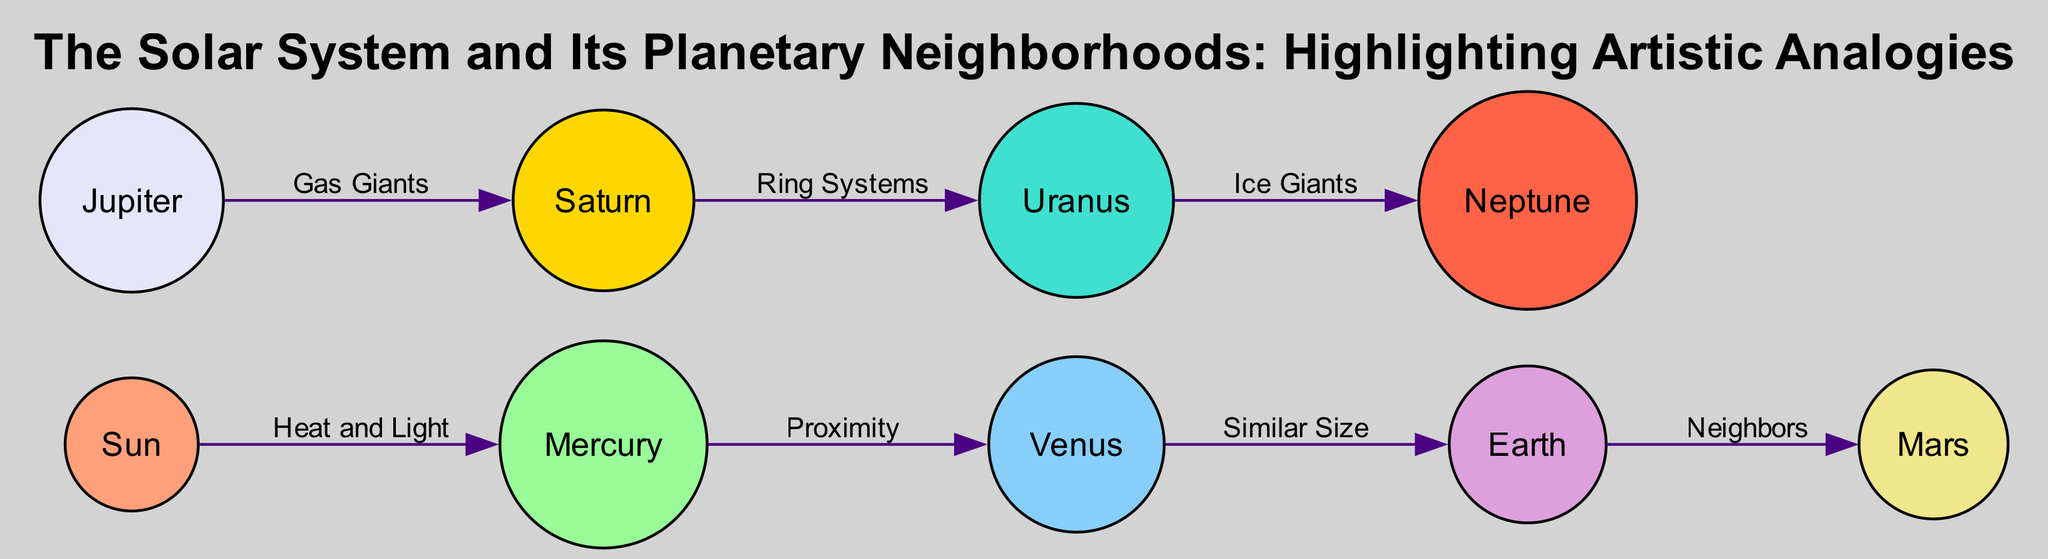What is the central star in the diagram? The diagram labels the "Sun" as the central star, indicating its importance in the solar system and art analogy.
Answer: Sun How many planets are depicted in the diagram? Counting the nodes labeled with planet names, there are eight planets present in the diagram.
Answer: Eight Which planet is symbolized by fiery passion? The description for "Mars" explicitly ties it to the symbolism of fiery passion in creativity.
Answer: Mars What connects Earth to Mars in the diagram? The edge labeled "Neighbors" highlights the direct connection and proximity of Earth to Mars.
Answer: Neighbors Which planets are categorized as gas giants? The diagram indicates that "Jupiter" and "Saturn" are linked by the label "Gas Giants", marking them as a specific category of planets.
Answer: Jupiter and Saturn How does Venus relate to Earth? The edge labeled "Similar Size" shows that Venus is directly connected to Earth, emphasizing their comparative dimensions.
Answer: Similar Size What does Saturn represent in the artistic analogies? The description states that "Saturn" illustrates intricate details in an artwork, akin to the visual complexity of art.
Answer: Intricate details Which planet represents the farthest reach of imagination? According to the diagram's depiction, "Neptune" is described as the planet that symbolizes the farthest reaches of imagination.
Answer: Neptune What color represents the node for Uranus in the diagram? The diagram indicates that node colors are assigned sequentially, and Uranus corresponds to a specific color in the provided palette.
Answer: Not specified but part of the color scheme 